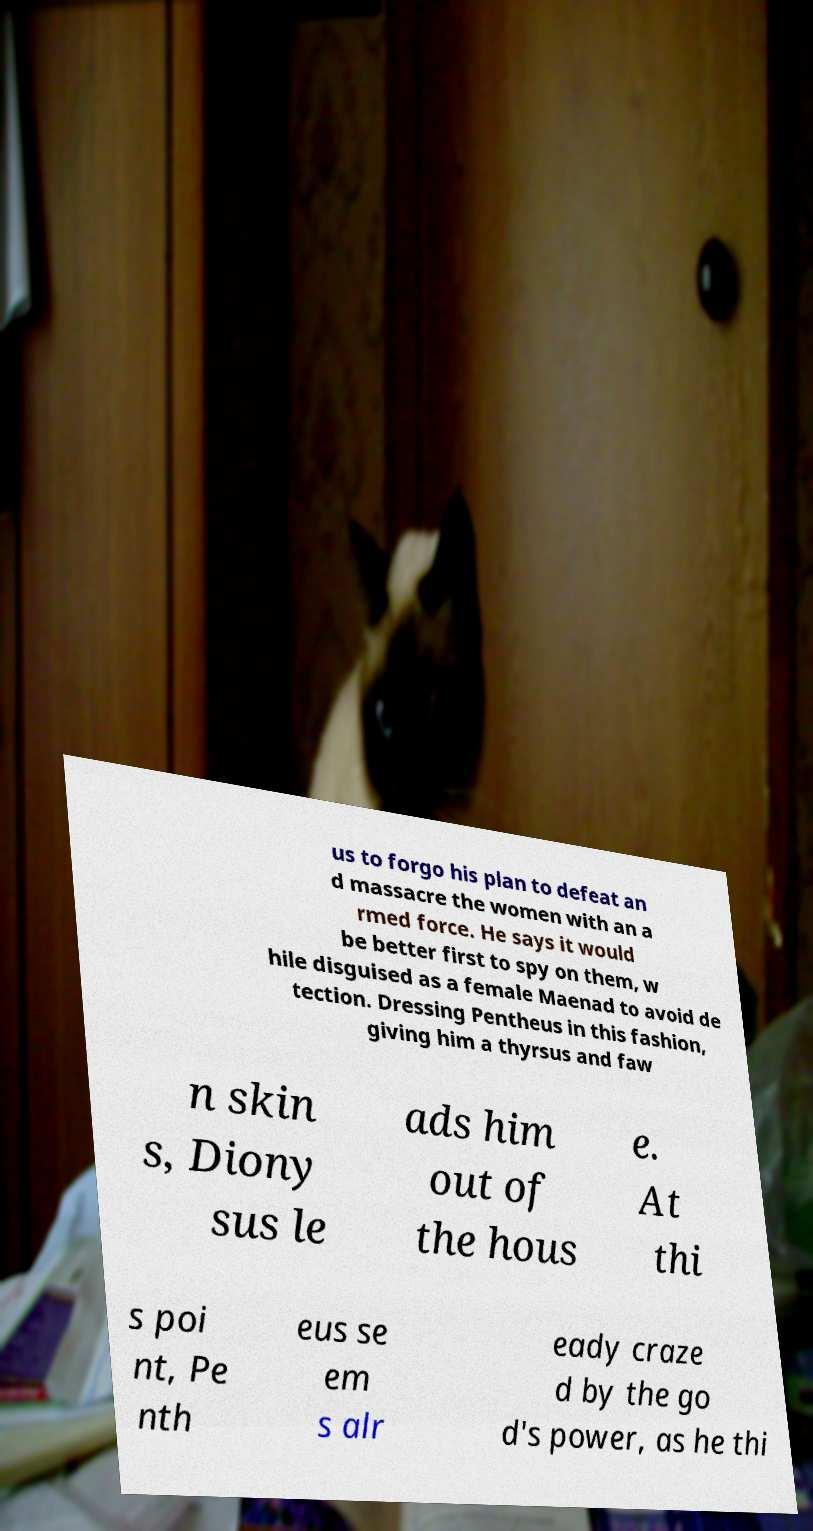Please identify and transcribe the text found in this image. us to forgo his plan to defeat an d massacre the women with an a rmed force. He says it would be better first to spy on them, w hile disguised as a female Maenad to avoid de tection. Dressing Pentheus in this fashion, giving him a thyrsus and faw n skin s, Diony sus le ads him out of the hous e. At thi s poi nt, Pe nth eus se em s alr eady craze d by the go d's power, as he thi 